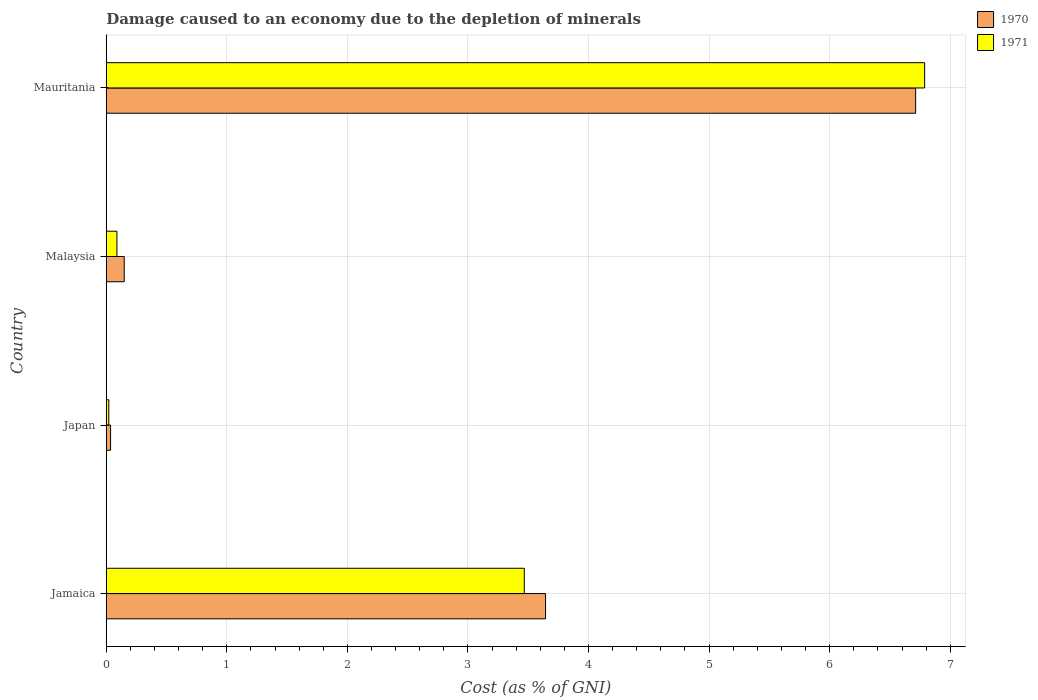How many different coloured bars are there?
Keep it short and to the point. 2. How many bars are there on the 2nd tick from the bottom?
Ensure brevity in your answer.  2. What is the label of the 4th group of bars from the top?
Offer a terse response. Jamaica. What is the cost of damage caused due to the depletion of minerals in 1971 in Japan?
Your answer should be very brief. 0.02. Across all countries, what is the maximum cost of damage caused due to the depletion of minerals in 1970?
Your answer should be very brief. 6.71. Across all countries, what is the minimum cost of damage caused due to the depletion of minerals in 1971?
Offer a terse response. 0.02. In which country was the cost of damage caused due to the depletion of minerals in 1971 maximum?
Give a very brief answer. Mauritania. In which country was the cost of damage caused due to the depletion of minerals in 1970 minimum?
Keep it short and to the point. Japan. What is the total cost of damage caused due to the depletion of minerals in 1971 in the graph?
Make the answer very short. 10.36. What is the difference between the cost of damage caused due to the depletion of minerals in 1971 in Japan and that in Malaysia?
Your answer should be very brief. -0.07. What is the difference between the cost of damage caused due to the depletion of minerals in 1970 in Mauritania and the cost of damage caused due to the depletion of minerals in 1971 in Malaysia?
Keep it short and to the point. 6.62. What is the average cost of damage caused due to the depletion of minerals in 1970 per country?
Keep it short and to the point. 2.64. What is the difference between the cost of damage caused due to the depletion of minerals in 1970 and cost of damage caused due to the depletion of minerals in 1971 in Jamaica?
Ensure brevity in your answer.  0.18. In how many countries, is the cost of damage caused due to the depletion of minerals in 1971 greater than 1 %?
Give a very brief answer. 2. What is the ratio of the cost of damage caused due to the depletion of minerals in 1970 in Japan to that in Mauritania?
Keep it short and to the point. 0.01. Is the cost of damage caused due to the depletion of minerals in 1970 in Jamaica less than that in Mauritania?
Ensure brevity in your answer.  Yes. What is the difference between the highest and the second highest cost of damage caused due to the depletion of minerals in 1970?
Offer a terse response. 3.07. What is the difference between the highest and the lowest cost of damage caused due to the depletion of minerals in 1971?
Your answer should be very brief. 6.77. In how many countries, is the cost of damage caused due to the depletion of minerals in 1970 greater than the average cost of damage caused due to the depletion of minerals in 1970 taken over all countries?
Give a very brief answer. 2. What does the 2nd bar from the top in Japan represents?
Keep it short and to the point. 1970. What does the 1st bar from the bottom in Malaysia represents?
Give a very brief answer. 1970. How many bars are there?
Ensure brevity in your answer.  8. Are all the bars in the graph horizontal?
Your answer should be compact. Yes. What is the difference between two consecutive major ticks on the X-axis?
Give a very brief answer. 1. Does the graph contain grids?
Provide a succinct answer. Yes. Where does the legend appear in the graph?
Make the answer very short. Top right. How many legend labels are there?
Give a very brief answer. 2. How are the legend labels stacked?
Offer a very short reply. Vertical. What is the title of the graph?
Make the answer very short. Damage caused to an economy due to the depletion of minerals. Does "1976" appear as one of the legend labels in the graph?
Offer a terse response. No. What is the label or title of the X-axis?
Keep it short and to the point. Cost (as % of GNI). What is the Cost (as % of GNI) of 1970 in Jamaica?
Keep it short and to the point. 3.64. What is the Cost (as % of GNI) in 1971 in Jamaica?
Your answer should be very brief. 3.47. What is the Cost (as % of GNI) in 1970 in Japan?
Your answer should be very brief. 0.04. What is the Cost (as % of GNI) in 1971 in Japan?
Provide a succinct answer. 0.02. What is the Cost (as % of GNI) of 1970 in Malaysia?
Offer a very short reply. 0.15. What is the Cost (as % of GNI) in 1971 in Malaysia?
Your response must be concise. 0.09. What is the Cost (as % of GNI) in 1970 in Mauritania?
Keep it short and to the point. 6.71. What is the Cost (as % of GNI) of 1971 in Mauritania?
Provide a succinct answer. 6.79. Across all countries, what is the maximum Cost (as % of GNI) of 1970?
Your answer should be compact. 6.71. Across all countries, what is the maximum Cost (as % of GNI) of 1971?
Provide a succinct answer. 6.79. Across all countries, what is the minimum Cost (as % of GNI) of 1970?
Provide a short and direct response. 0.04. Across all countries, what is the minimum Cost (as % of GNI) in 1971?
Your response must be concise. 0.02. What is the total Cost (as % of GNI) of 1970 in the graph?
Offer a terse response. 10.54. What is the total Cost (as % of GNI) of 1971 in the graph?
Your answer should be compact. 10.36. What is the difference between the Cost (as % of GNI) in 1970 in Jamaica and that in Japan?
Provide a succinct answer. 3.61. What is the difference between the Cost (as % of GNI) in 1971 in Jamaica and that in Japan?
Your answer should be compact. 3.45. What is the difference between the Cost (as % of GNI) of 1970 in Jamaica and that in Malaysia?
Provide a succinct answer. 3.49. What is the difference between the Cost (as % of GNI) in 1971 in Jamaica and that in Malaysia?
Keep it short and to the point. 3.38. What is the difference between the Cost (as % of GNI) in 1970 in Jamaica and that in Mauritania?
Provide a short and direct response. -3.07. What is the difference between the Cost (as % of GNI) in 1971 in Jamaica and that in Mauritania?
Provide a short and direct response. -3.32. What is the difference between the Cost (as % of GNI) in 1970 in Japan and that in Malaysia?
Offer a very short reply. -0.11. What is the difference between the Cost (as % of GNI) in 1971 in Japan and that in Malaysia?
Ensure brevity in your answer.  -0.07. What is the difference between the Cost (as % of GNI) of 1970 in Japan and that in Mauritania?
Your answer should be compact. -6.68. What is the difference between the Cost (as % of GNI) in 1971 in Japan and that in Mauritania?
Provide a short and direct response. -6.77. What is the difference between the Cost (as % of GNI) in 1970 in Malaysia and that in Mauritania?
Your response must be concise. -6.56. What is the difference between the Cost (as % of GNI) of 1971 in Malaysia and that in Mauritania?
Your response must be concise. -6.7. What is the difference between the Cost (as % of GNI) in 1970 in Jamaica and the Cost (as % of GNI) in 1971 in Japan?
Provide a succinct answer. 3.62. What is the difference between the Cost (as % of GNI) in 1970 in Jamaica and the Cost (as % of GNI) in 1971 in Malaysia?
Give a very brief answer. 3.55. What is the difference between the Cost (as % of GNI) of 1970 in Jamaica and the Cost (as % of GNI) of 1971 in Mauritania?
Offer a terse response. -3.14. What is the difference between the Cost (as % of GNI) in 1970 in Japan and the Cost (as % of GNI) in 1971 in Malaysia?
Keep it short and to the point. -0.05. What is the difference between the Cost (as % of GNI) in 1970 in Japan and the Cost (as % of GNI) in 1971 in Mauritania?
Give a very brief answer. -6.75. What is the difference between the Cost (as % of GNI) of 1970 in Malaysia and the Cost (as % of GNI) of 1971 in Mauritania?
Your answer should be compact. -6.64. What is the average Cost (as % of GNI) in 1970 per country?
Keep it short and to the point. 2.64. What is the average Cost (as % of GNI) of 1971 per country?
Make the answer very short. 2.59. What is the difference between the Cost (as % of GNI) of 1970 and Cost (as % of GNI) of 1971 in Jamaica?
Your answer should be very brief. 0.18. What is the difference between the Cost (as % of GNI) in 1970 and Cost (as % of GNI) in 1971 in Japan?
Your answer should be very brief. 0.01. What is the difference between the Cost (as % of GNI) in 1970 and Cost (as % of GNI) in 1971 in Malaysia?
Make the answer very short. 0.06. What is the difference between the Cost (as % of GNI) of 1970 and Cost (as % of GNI) of 1971 in Mauritania?
Ensure brevity in your answer.  -0.07. What is the ratio of the Cost (as % of GNI) of 1970 in Jamaica to that in Japan?
Your answer should be very brief. 101.28. What is the ratio of the Cost (as % of GNI) of 1971 in Jamaica to that in Japan?
Offer a terse response. 162.58. What is the ratio of the Cost (as % of GNI) in 1970 in Jamaica to that in Malaysia?
Your answer should be compact. 24.42. What is the ratio of the Cost (as % of GNI) in 1971 in Jamaica to that in Malaysia?
Your response must be concise. 39.09. What is the ratio of the Cost (as % of GNI) of 1970 in Jamaica to that in Mauritania?
Your answer should be very brief. 0.54. What is the ratio of the Cost (as % of GNI) of 1971 in Jamaica to that in Mauritania?
Your answer should be very brief. 0.51. What is the ratio of the Cost (as % of GNI) of 1970 in Japan to that in Malaysia?
Ensure brevity in your answer.  0.24. What is the ratio of the Cost (as % of GNI) of 1971 in Japan to that in Malaysia?
Provide a short and direct response. 0.24. What is the ratio of the Cost (as % of GNI) in 1970 in Japan to that in Mauritania?
Keep it short and to the point. 0.01. What is the ratio of the Cost (as % of GNI) in 1971 in Japan to that in Mauritania?
Offer a terse response. 0. What is the ratio of the Cost (as % of GNI) of 1970 in Malaysia to that in Mauritania?
Make the answer very short. 0.02. What is the ratio of the Cost (as % of GNI) in 1971 in Malaysia to that in Mauritania?
Give a very brief answer. 0.01. What is the difference between the highest and the second highest Cost (as % of GNI) in 1970?
Provide a short and direct response. 3.07. What is the difference between the highest and the second highest Cost (as % of GNI) in 1971?
Provide a succinct answer. 3.32. What is the difference between the highest and the lowest Cost (as % of GNI) in 1970?
Provide a short and direct response. 6.68. What is the difference between the highest and the lowest Cost (as % of GNI) of 1971?
Offer a very short reply. 6.77. 